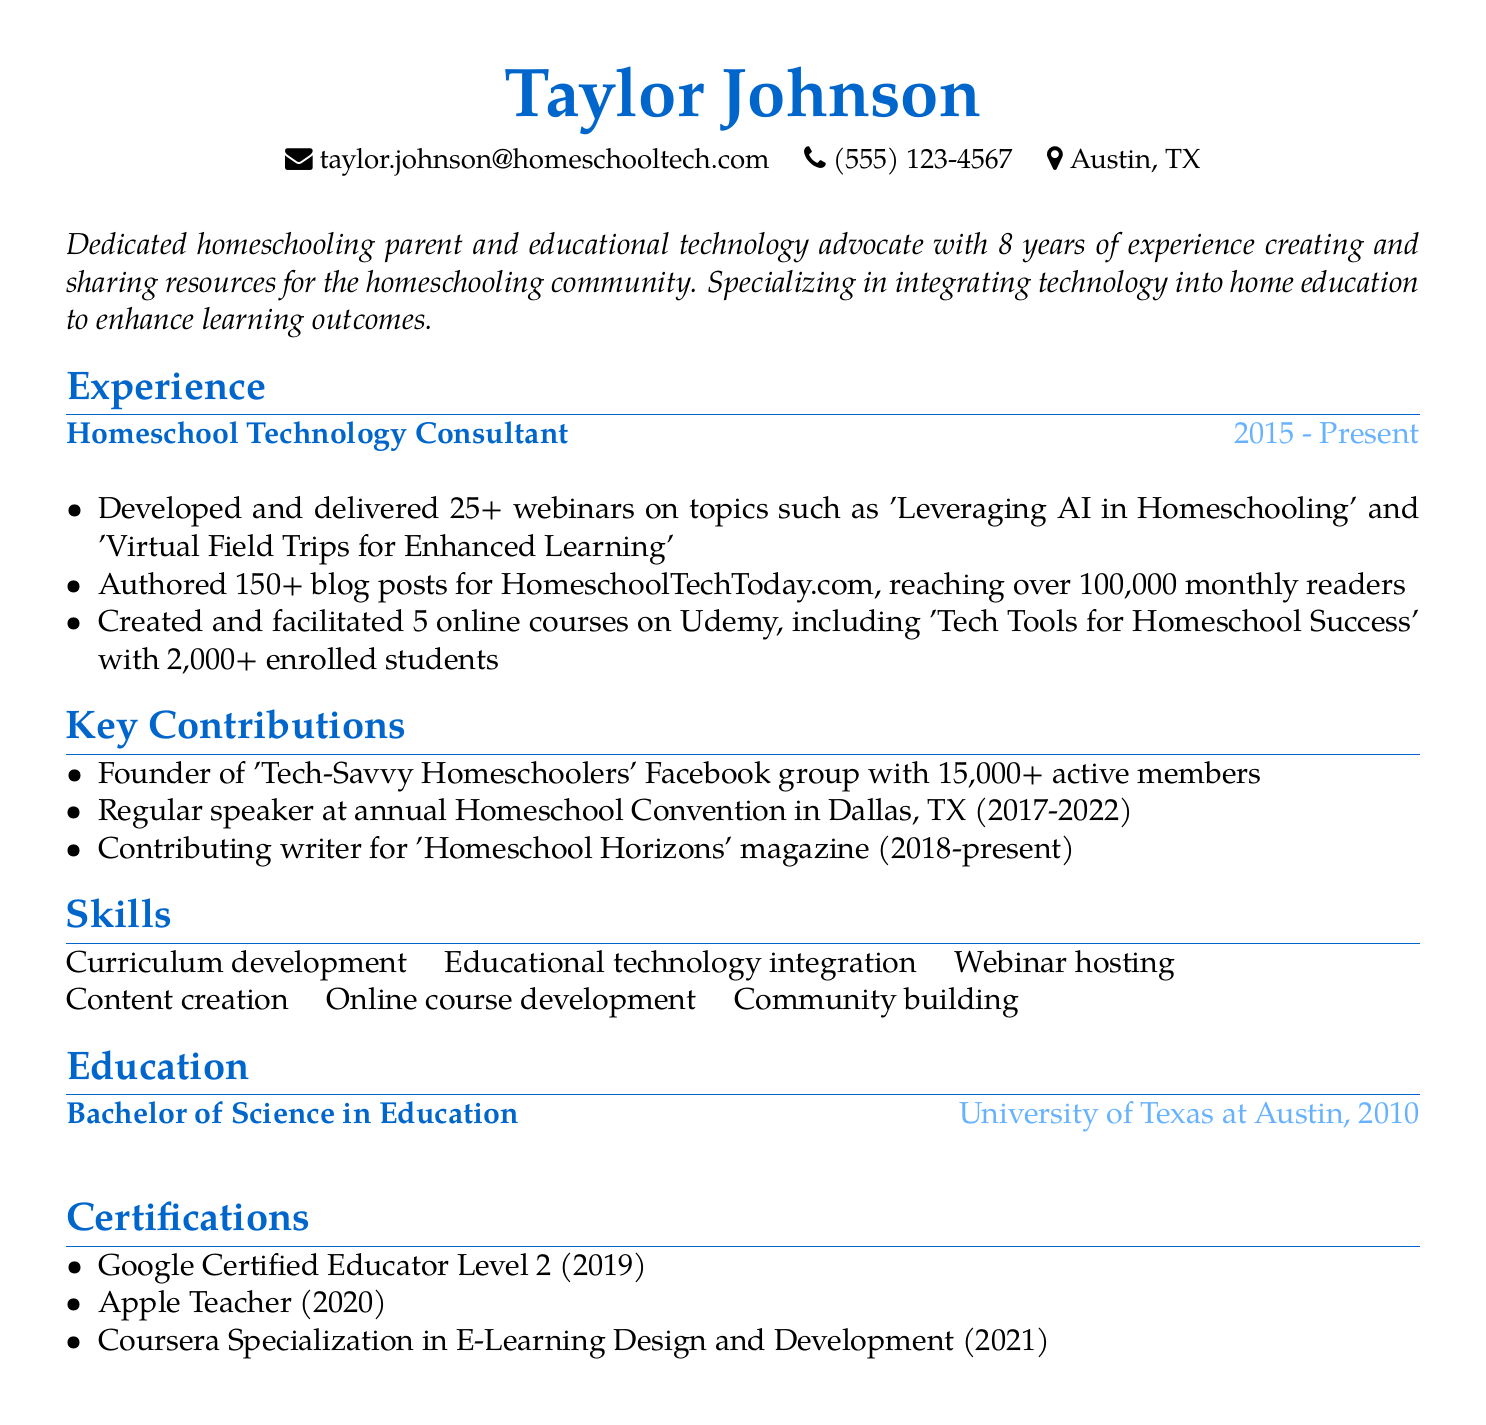What is the name of the individual in this CV? The name is the first piece of information presented in the document.
Answer: Taylor Johnson How many webinars has Taylor Johnson developed and delivered? This information is found in the experience section detailing achievements in the role of Homeschool Technology Consultant.
Answer: 25+ What is the location of Taylor Johnson? The location is one of the personal information details provided at the beginning of the document.
Answer: Austin, TX In what year did Taylor Johnson obtain their degree? The year is stated in the education section under the degree information.
Answer: 2010 What is the name of the Facebook group founded by Taylor Johnson? The name is detailed in the contributions section, indicating a key contribution to the homeschooling community.
Answer: Tech-Savvy Homeschoolers How many active members does the Facebook group have? This information is in the contributions section indicating the impact of the group.
Answer: 15,000+ What is the title of one of Taylor Johnson's online courses? The title is provided in the experience section among the courses developed by Taylor.
Answer: Tech Tools for Homeschool Success How long has Taylor Johnson been a consultant? The duration stated in the experience section indicates the length of time in this role.
Answer: 2015 - Present What type of certification did Taylor Johnson receive in 2019? The specific certification is listed in the certifications section, providing details on professional credentials.
Answer: Google Certified Educator Level 2 In which publication does Taylor Johnson contribute as a writer? This is specified in the contributions section highlighting a key writing role.
Answer: Homeschool Horizons 